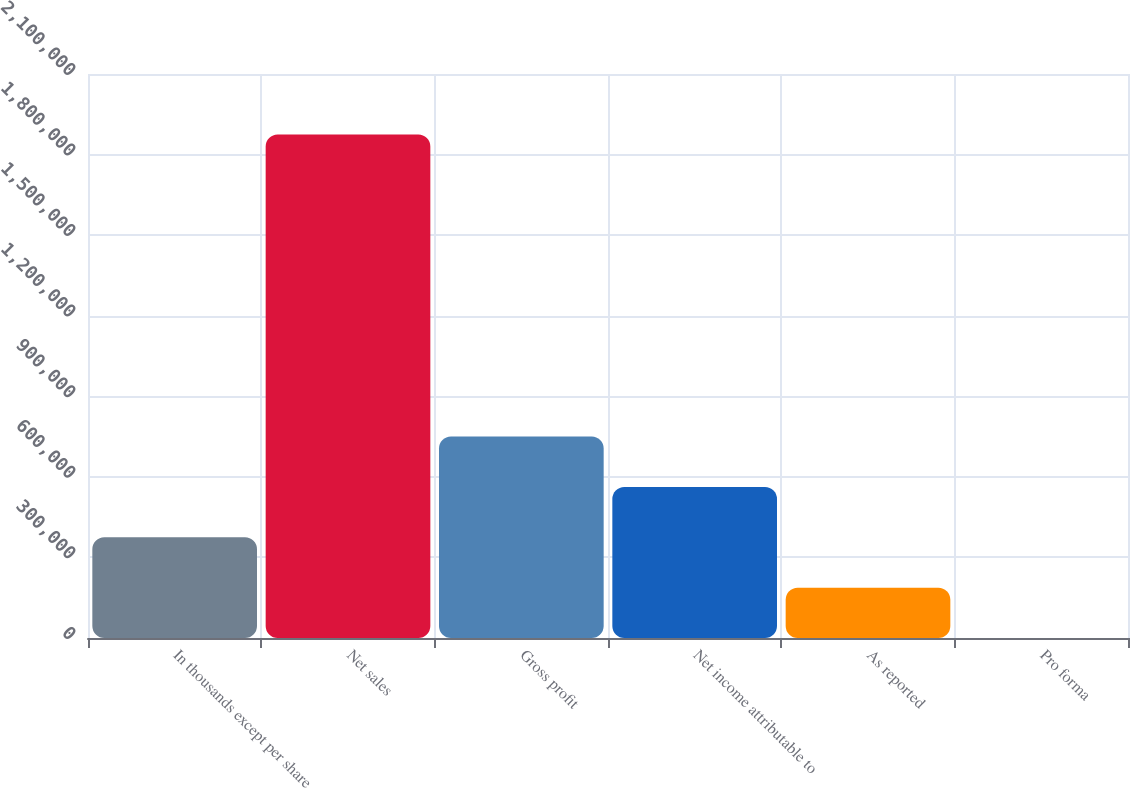<chart> <loc_0><loc_0><loc_500><loc_500><bar_chart><fcel>In thousands except per share<fcel>Net sales<fcel>Gross profit<fcel>Net income attributable to<fcel>As reported<fcel>Pro forma<nl><fcel>375037<fcel>1.87518e+06<fcel>750071<fcel>562554<fcel>187520<fcel>2.39<nl></chart> 